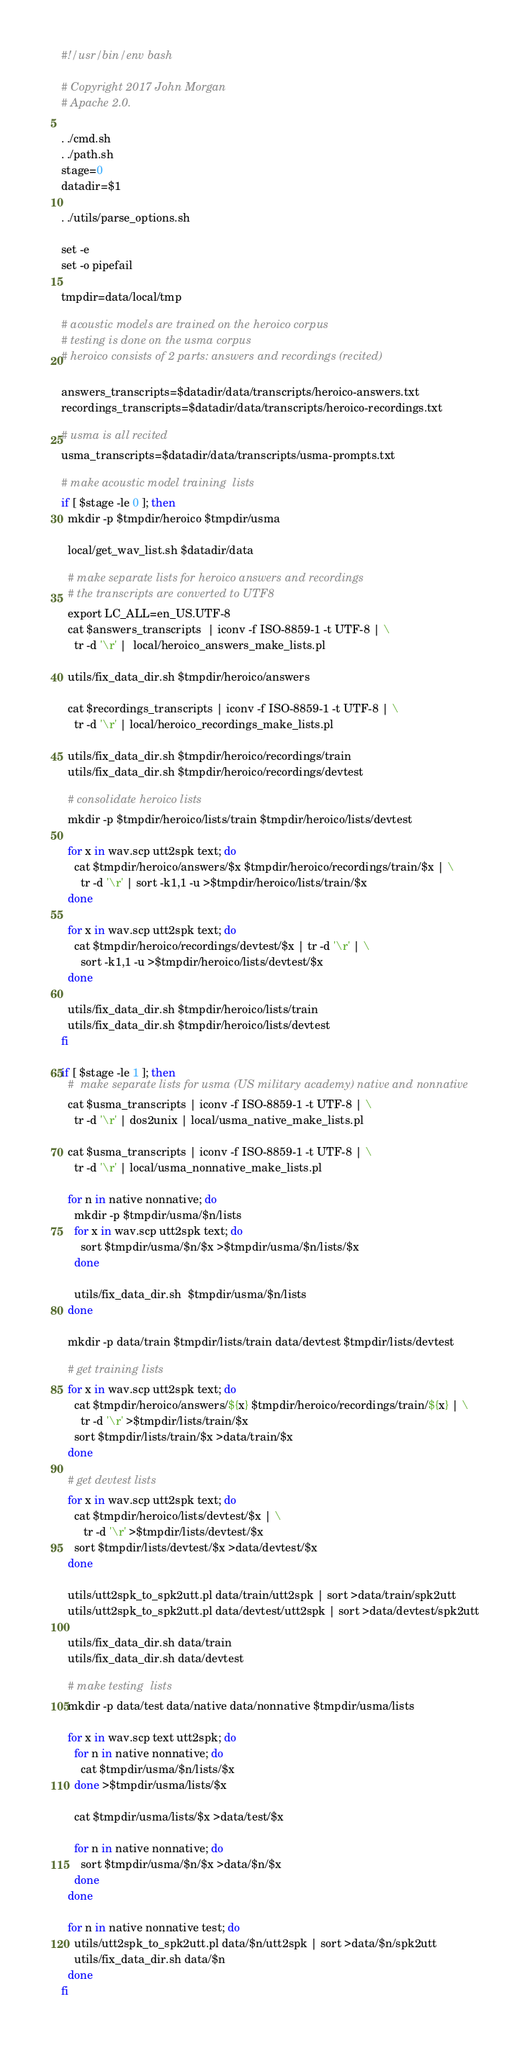<code> <loc_0><loc_0><loc_500><loc_500><_Bash_>#!/usr/bin/env bash

# Copyright 2017 John Morgan
# Apache 2.0.

. ./cmd.sh
. ./path.sh
stage=0
datadir=$1

. ./utils/parse_options.sh

set -e
set -o pipefail

tmpdir=data/local/tmp

# acoustic models are trained on the heroico corpus
# testing is done on the usma corpus
# heroico consists of 2 parts: answers and recordings (recited)

answers_transcripts=$datadir/data/transcripts/heroico-answers.txt
recordings_transcripts=$datadir/data/transcripts/heroico-recordings.txt

# usma is all recited
usma_transcripts=$datadir/data/transcripts/usma-prompts.txt

# make acoustic model training  lists
if [ $stage -le 0 ]; then
  mkdir -p $tmpdir/heroico $tmpdir/usma

  local/get_wav_list.sh $datadir/data

  # make separate lists for heroico answers and recordings
  # the transcripts are converted to UTF8
  export LC_ALL=en_US.UTF-8
  cat $answers_transcripts  | iconv -f ISO-8859-1 -t UTF-8 | \
    tr -d '\r' |  local/heroico_answers_make_lists.pl

  utils/fix_data_dir.sh $tmpdir/heroico/answers

  cat $recordings_transcripts | iconv -f ISO-8859-1 -t UTF-8 | \
    tr -d '\r' | local/heroico_recordings_make_lists.pl

  utils/fix_data_dir.sh $tmpdir/heroico/recordings/train
  utils/fix_data_dir.sh $tmpdir/heroico/recordings/devtest

  # consolidate heroico lists
  mkdir -p $tmpdir/heroico/lists/train $tmpdir/heroico/lists/devtest

  for x in wav.scp utt2spk text; do
    cat $tmpdir/heroico/answers/$x $tmpdir/heroico/recordings/train/$x | \
      tr -d '\r' | sort -k1,1 -u >$tmpdir/heroico/lists/train/$x
  done

  for x in wav.scp utt2spk text; do
    cat $tmpdir/heroico/recordings/devtest/$x | tr -d '\r' | \
      sort -k1,1 -u >$tmpdir/heroico/lists/devtest/$x
  done

  utils/fix_data_dir.sh $tmpdir/heroico/lists/train
  utils/fix_data_dir.sh $tmpdir/heroico/lists/devtest
fi

if [ $stage -le 1 ]; then
  #  make separate lists for usma (US military academy) native and nonnative
  cat $usma_transcripts | iconv -f ISO-8859-1 -t UTF-8 | \
    tr -d '\r' | dos2unix | local/usma_native_make_lists.pl

  cat $usma_transcripts | iconv -f ISO-8859-1 -t UTF-8 | \
    tr -d '\r' | local/usma_nonnative_make_lists.pl

  for n in native nonnative; do
    mkdir -p $tmpdir/usma/$n/lists
    for x in wav.scp utt2spk text; do
      sort $tmpdir/usma/$n/$x >$tmpdir/usma/$n/lists/$x
    done

    utils/fix_data_dir.sh  $tmpdir/usma/$n/lists
  done

  mkdir -p data/train $tmpdir/lists/train data/devtest $tmpdir/lists/devtest

  # get training lists
  for x in wav.scp utt2spk text; do
    cat $tmpdir/heroico/answers/${x} $tmpdir/heroico/recordings/train/${x} | \
      tr -d '\r' >$tmpdir/lists/train/$x
    sort $tmpdir/lists/train/$x >data/train/$x
  done

  # get devtest lists
  for x in wav.scp utt2spk text; do
    cat $tmpdir/heroico/lists/devtest/$x | \
       tr -d '\r' >$tmpdir/lists/devtest/$x
    sort $tmpdir/lists/devtest/$x >data/devtest/$x
  done

  utils/utt2spk_to_spk2utt.pl data/train/utt2spk | sort >data/train/spk2utt
  utils/utt2spk_to_spk2utt.pl data/devtest/utt2spk | sort >data/devtest/spk2utt

  utils/fix_data_dir.sh data/train
  utils/fix_data_dir.sh data/devtest

  # make testing  lists
  mkdir -p data/test data/native data/nonnative $tmpdir/usma/lists

  for x in wav.scp text utt2spk; do
    for n in native nonnative; do
      cat $tmpdir/usma/$n/lists/$x
    done >$tmpdir/usma/lists/$x

    cat $tmpdir/usma/lists/$x >data/test/$x

    for n in native nonnative; do
      sort $tmpdir/usma/$n/$x >data/$n/$x
    done
  done

  for n in native nonnative test; do
    utils/utt2spk_to_spk2utt.pl data/$n/utt2spk | sort >data/$n/spk2utt
    utils/fix_data_dir.sh data/$n
  done
fi
</code> 